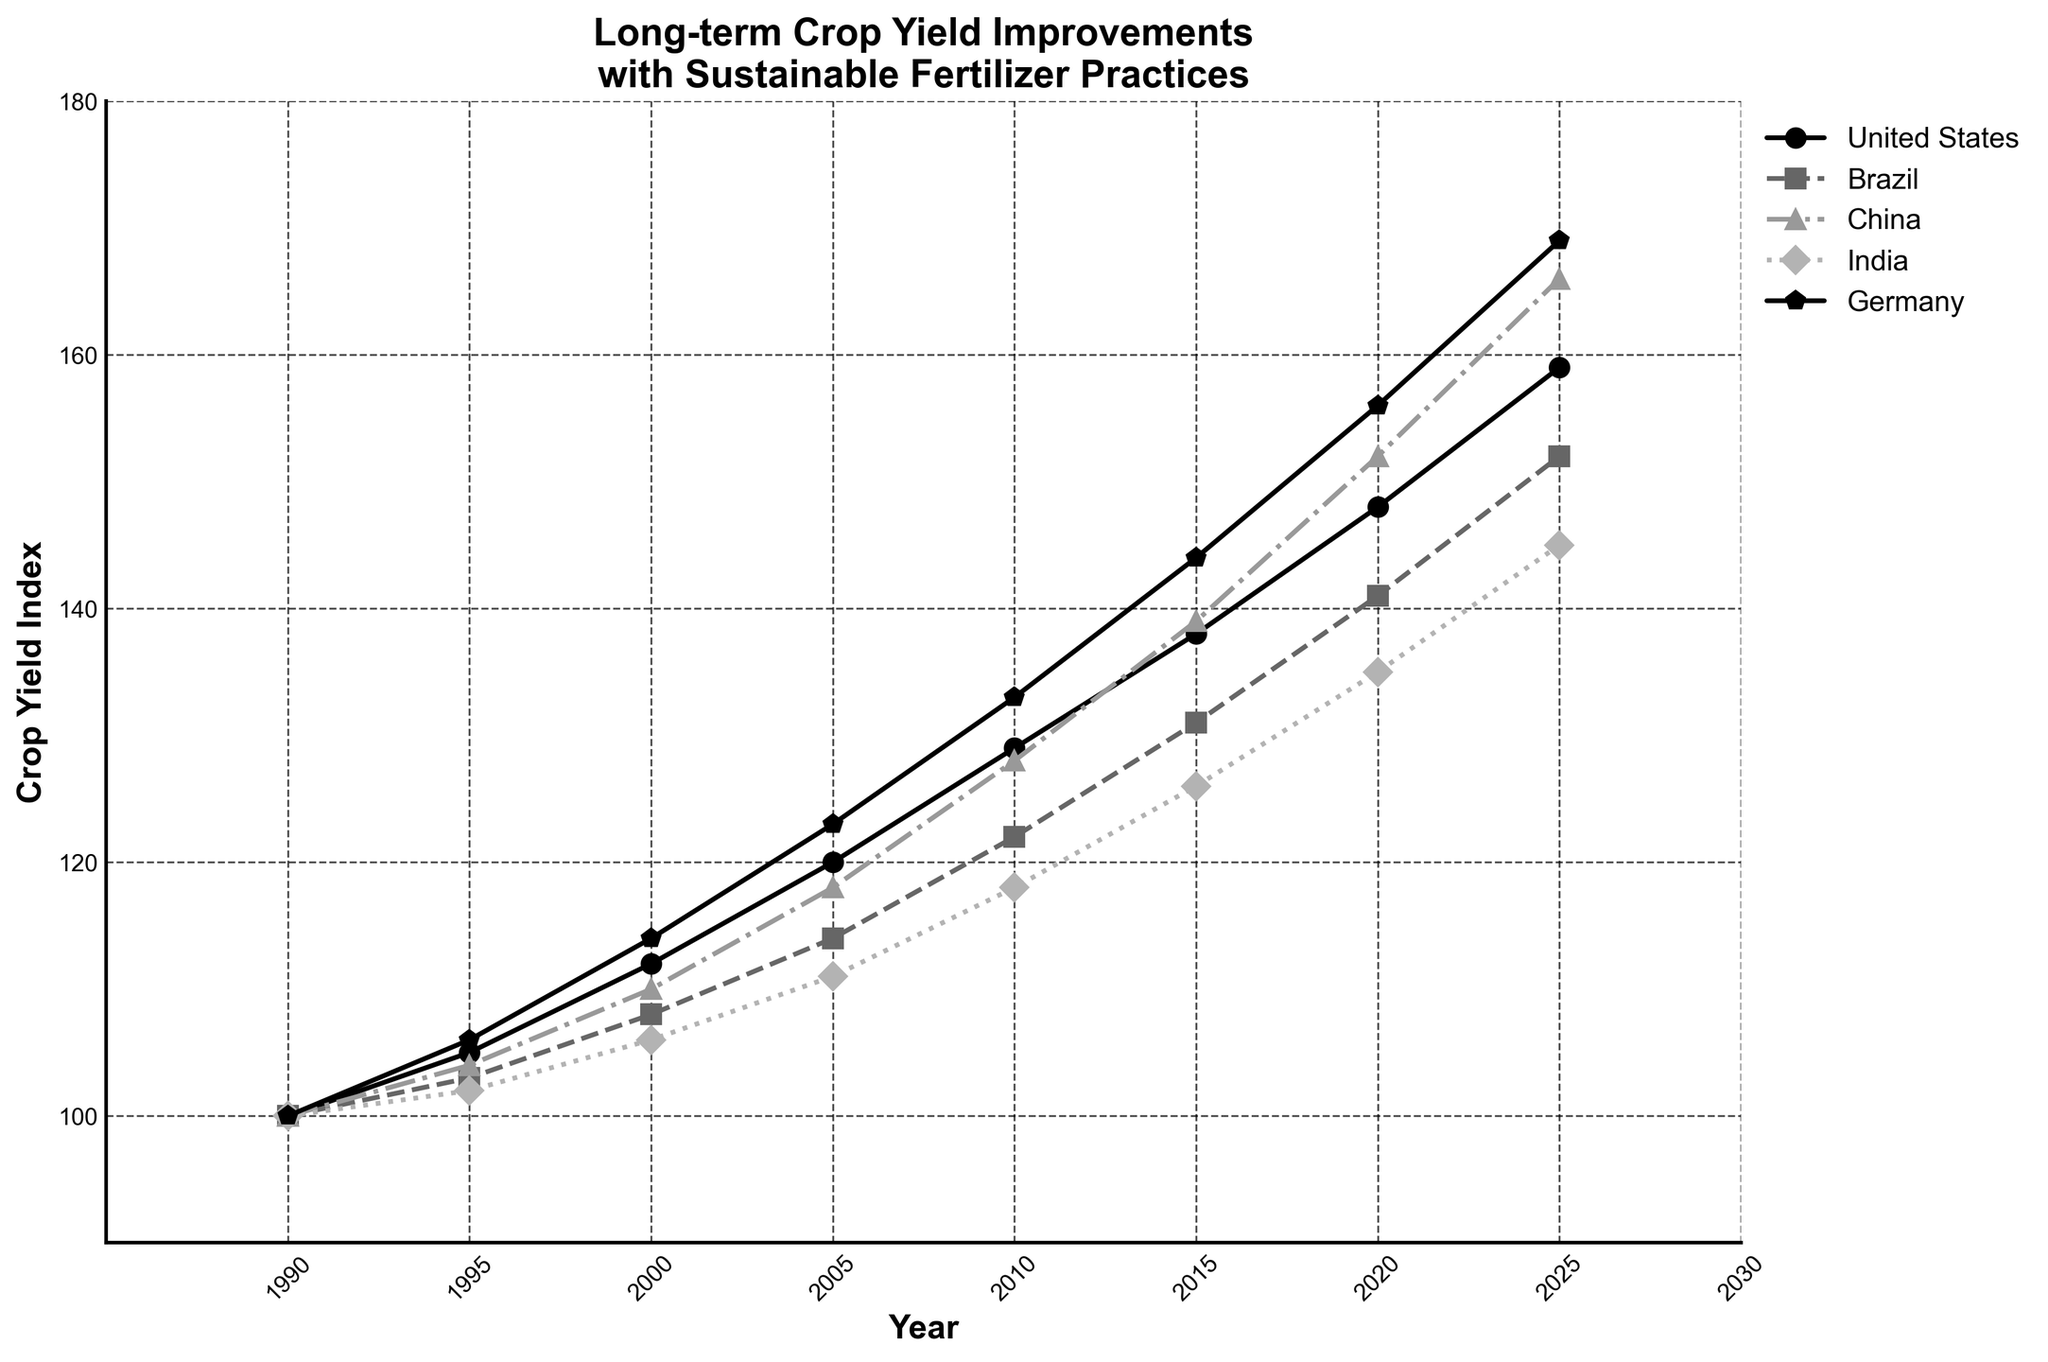What's the crop yield index for China in 2015? Locate the year 2015 on the x-axis, then trace upwards to find the data point associated with China. The data point corresponds to a value of 139.
Answer: 139 Which country had the lowest crop yield index in 2005? Identify the year 2005 on the x-axis, then compare the crop yield indices of all countries in that year. Brazil has the lowest value, which is 114.
Answer: Brazil Which years show the largest increase in crop yield index for India? Observe the data points for India across different years. The largest increase occurs between 2020 and 2025, rising from 135 to 145. The increase is 10 points.
Answer: 2020-2025 What is the average crop yield index for the United States from 1990 to 2000? Find the crop yield index for the United States in 1990, 1995, and 2000: 100, 105, and 112, respectively. Sum these values: 100 + 105 + 112 = 317, then divide by 3 to find the average: 317/3 ≈ 105.67
Answer: 105.67 How does the crop yield index change for Germany from 2010 to 2025? Examine Germany's crop yield indices in 2010, 2015, 2020, and 2025: 133, 144, 156, and 169. Calculate the differences: 144 - 133 = 11 (2010-2015), 156 - 144 = 12 (2015-2020), and 169 - 156 = 13 (2020-2025), showing a gradually increasing trend.
Answer: Increasing trend Between Brazil and China, which country has a higher crop yield index in 2020 and by how much? Locate the year 2020 on the x-axis, then find the crop yield indices for Brazil (141) and China (152). Subtract Brazil's value from China's: 152 - 141 = 11. Therefore, China has a higher index by 11 points.
Answer: China by 11 Which country shows the most consistent increase in crop yield index over the years? Analyze the trends of crop yield indices for all countries. The United States shows a steady and consistent increase without sharp rises or falls from 1990 to 2025.
Answer: United States What is the difference in crop yield index between 1990 and 2025 for Brazil? Find Brazil's crop yield indices for 1990 and 2025: 100 and 152, respectively. Calculate the difference: 152 - 100 = 52.
Answer: 52 In 2015, how much higher (in points) is Germany's crop yield index compared to India's? Locate the year 2015 on the x-axis and find the crop yield indices for Germany (144) and India (126). Subtract India's value from Germany's: 144 - 126 = 18.
Answer: 18 Which country has the steepest increase in crop yield index from 1990 to 2000? Identify the crop yield indices for all countries in 1990 and 2000. Calculate the difference for each country: United States (12), Brazil (8), China (10), India (6), and Germany (14). Germany has the steepest increase of 14 points.
Answer: Germany 